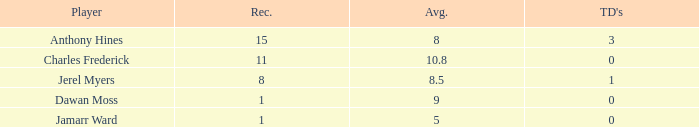What is the highest number of TDs when the Avg is larger than 8.5 and the Rec is less than 1? None. 